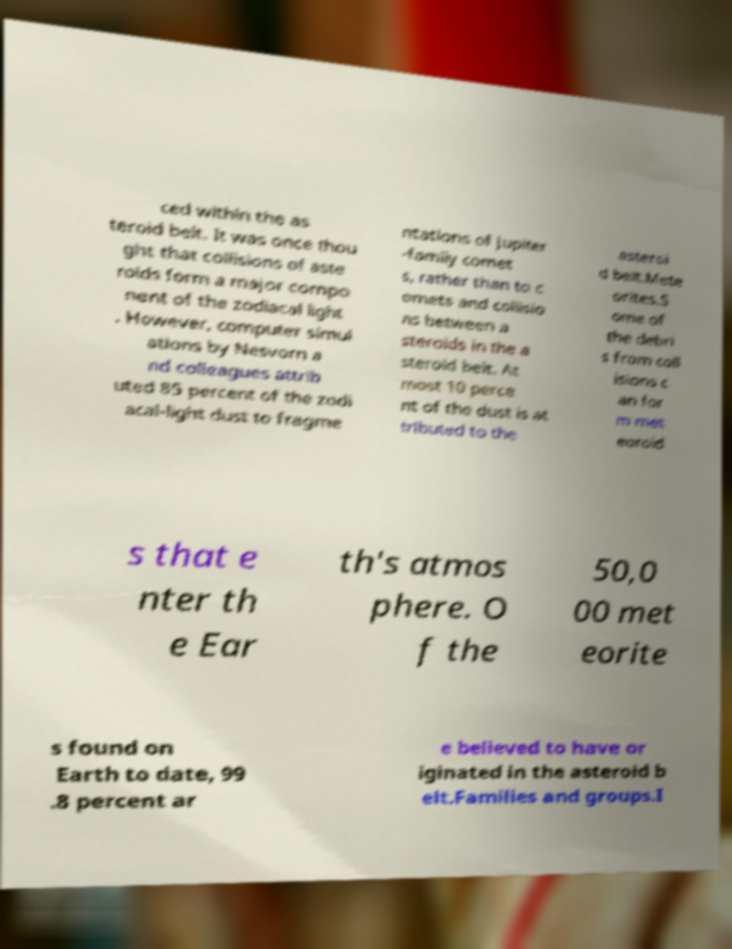Please read and relay the text visible in this image. What does it say? ced within the as teroid belt. It was once thou ght that collisions of aste roids form a major compo nent of the zodiacal light . However, computer simul ations by Nesvorn a nd colleagues attrib uted 85 percent of the zodi acal-light dust to fragme ntations of Jupiter -family comet s, rather than to c omets and collisio ns between a steroids in the a steroid belt. At most 10 perce nt of the dust is at tributed to the asteroi d belt.Mete orites.S ome of the debri s from coll isions c an for m met eoroid s that e nter th e Ear th's atmos phere. O f the 50,0 00 met eorite s found on Earth to date, 99 .8 percent ar e believed to have or iginated in the asteroid b elt.Families and groups.I 